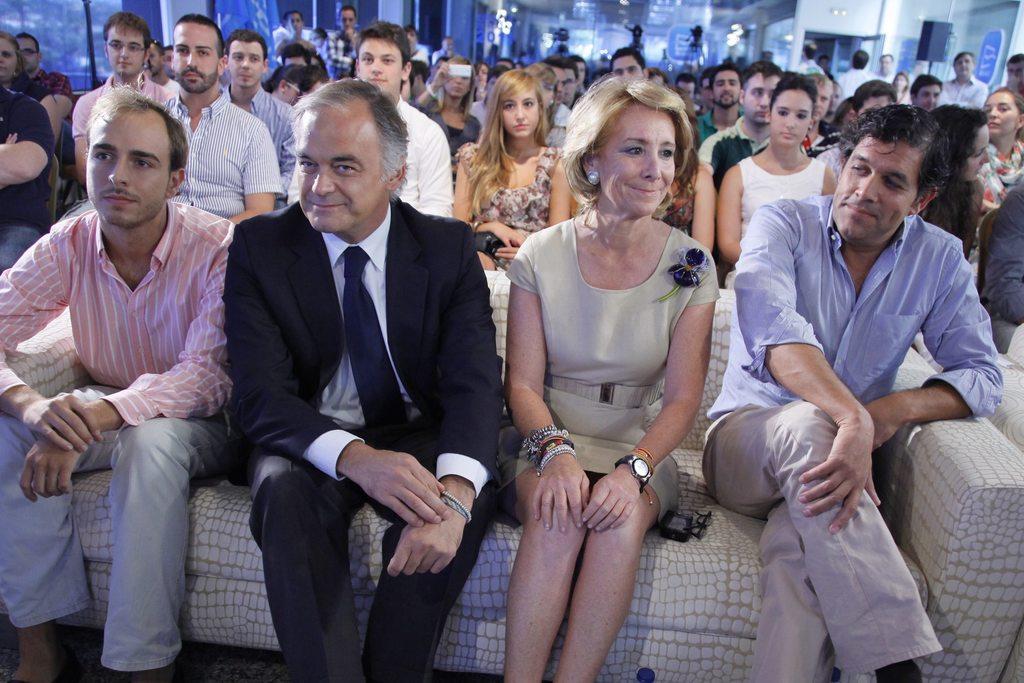Can you describe this image briefly? In this picture we can see there are four people sitting on a couch and other people are sitting on chairs. Behind the people there are blurred things. 